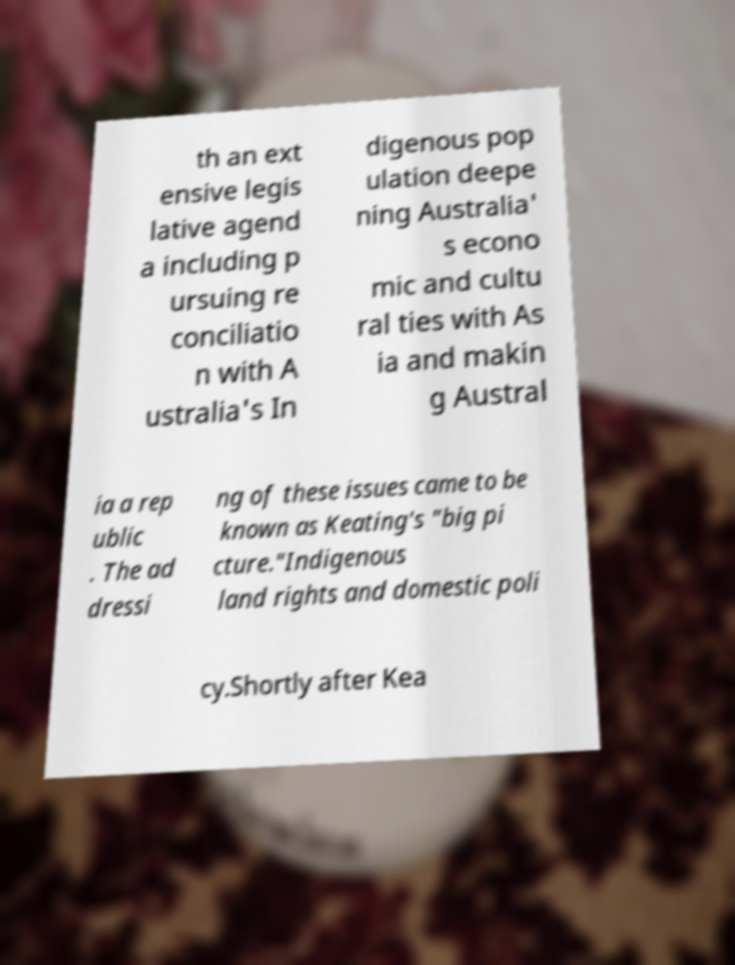There's text embedded in this image that I need extracted. Can you transcribe it verbatim? th an ext ensive legis lative agend a including p ursuing re conciliatio n with A ustralia's In digenous pop ulation deepe ning Australia' s econo mic and cultu ral ties with As ia and makin g Austral ia a rep ublic . The ad dressi ng of these issues came to be known as Keating's "big pi cture."Indigenous land rights and domestic poli cy.Shortly after Kea 